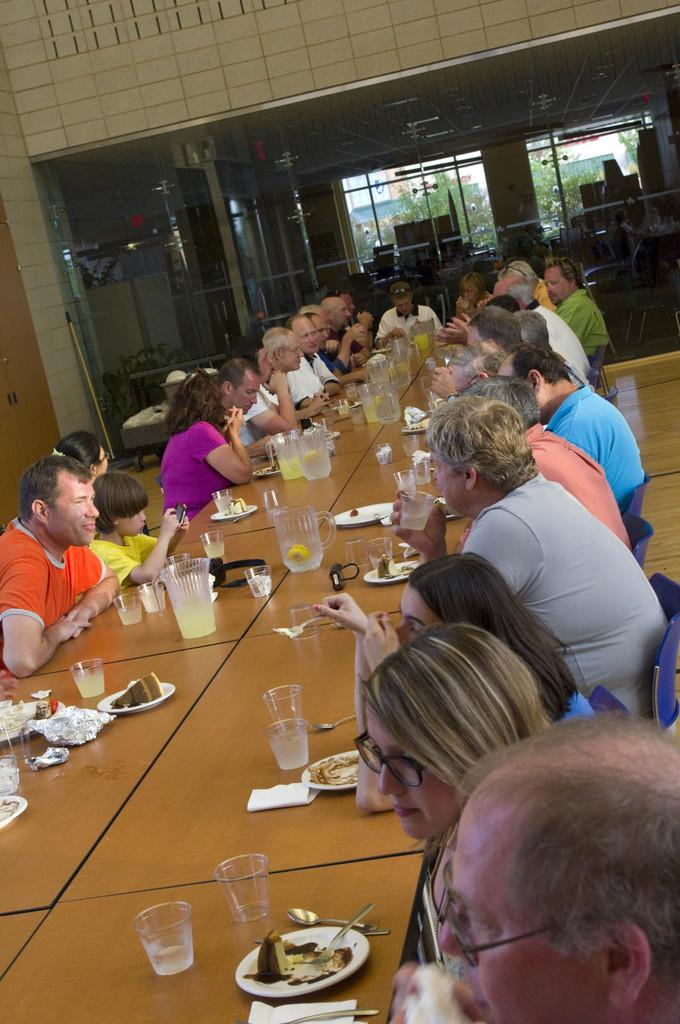What are the people in the image doing? The people in the image are sitting on chairs. What is on the table in the image? Jars, glasses, and plates are on the table in the image. Are there any other items on the table? Yes, there are other things on the table. What can be seen on the floor in the image? The floor is visible in the image. What is in the background of the image? There is a glass window and a wall in the background. What country is the plane flying over in the image? There is no plane present in the image, so it is not possible to determine the country it might be flying over. 